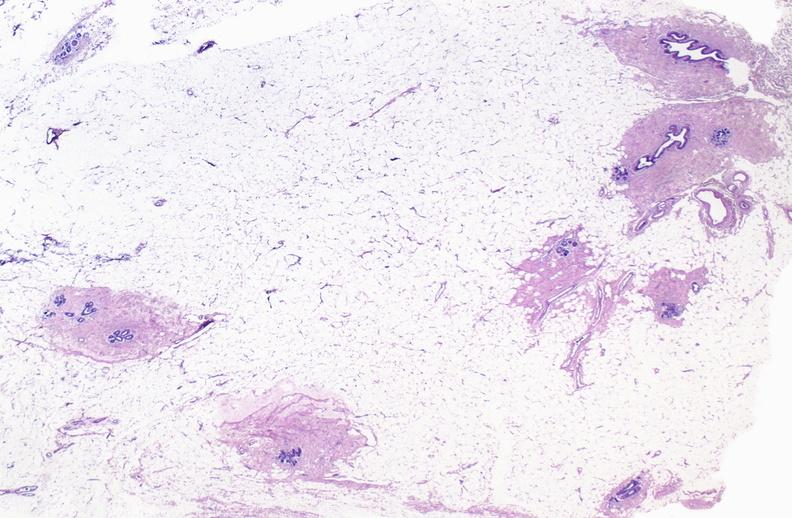does lower chest and abdomen anterior show normal breast?
Answer the question using a single word or phrase. No 